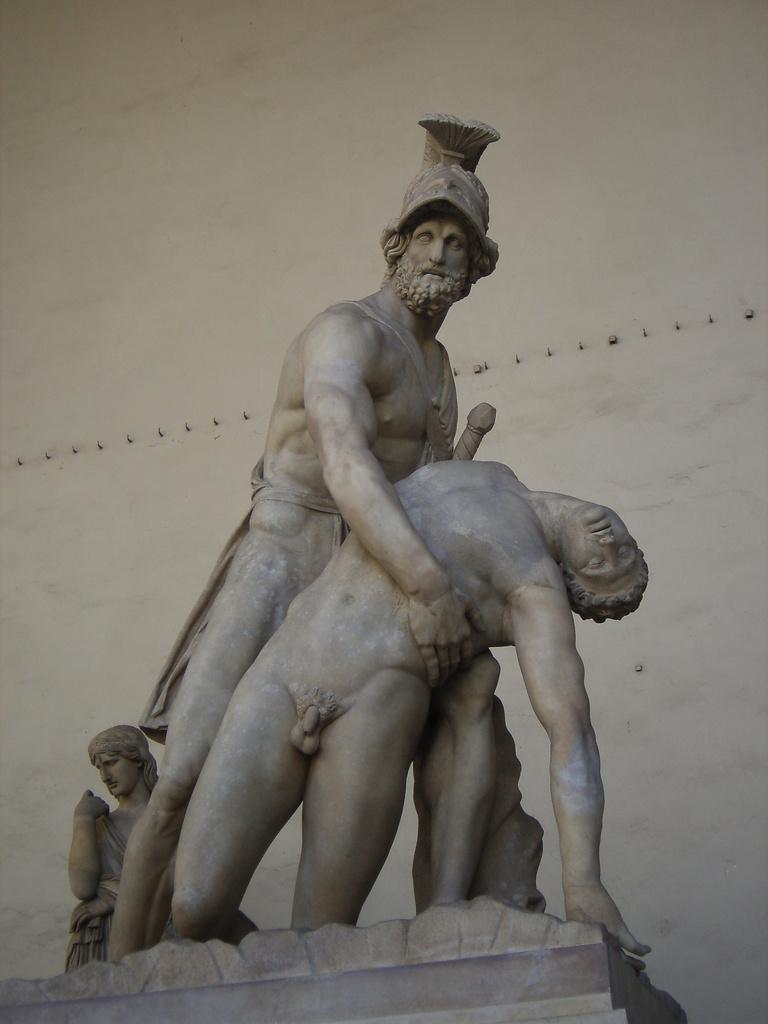What is the main subject of the image? There is a big statue in the image. What color is the background of the image? The background of the image is white. What can be seen on the surface of the statue? There are objects on the surface of the statue. How does the statue react to the earthquake in the image? There is no earthquake present in the image, so the statue's reaction cannot be determined. What color are the eyes of the statue in the image? The facts provided do not mention the statue's eyes, so we cannot determine their color. 